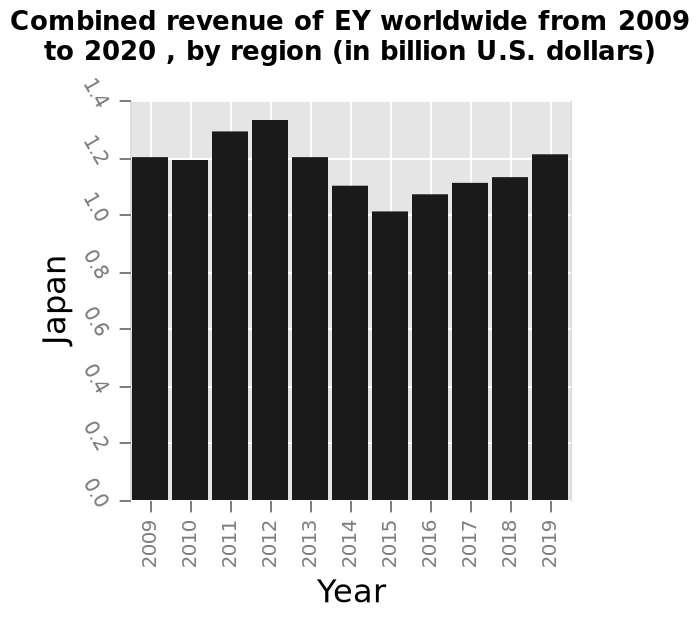<image>
Which region's revenue is displayed in the bar diagram? The revenue from different regions worldwide is displayed in the bar diagram. Has the company fully recovered to its highest level of income?  No, the company has yet to recover to its highest level of income in 2012. 